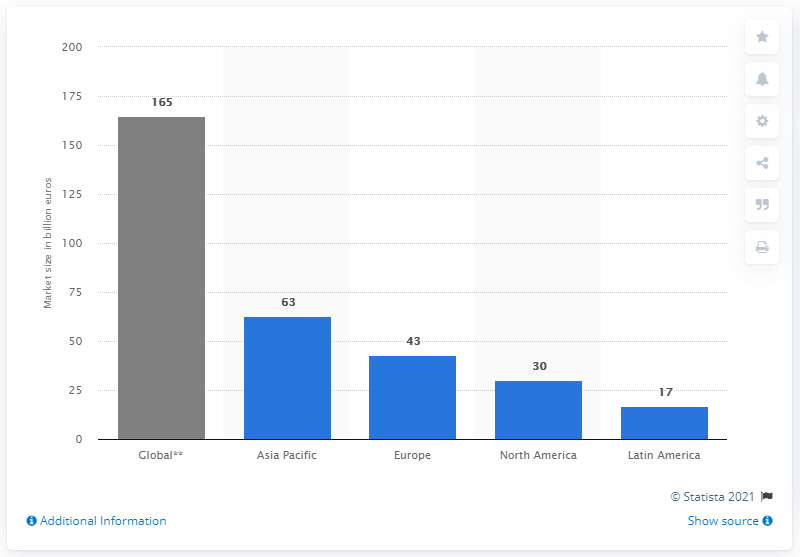Draw attention to some important aspects in this diagram. In 2012, the global market size was estimated to be approximately 165. In 2012, the market size of the Asia Pacific region was approximately 63. 